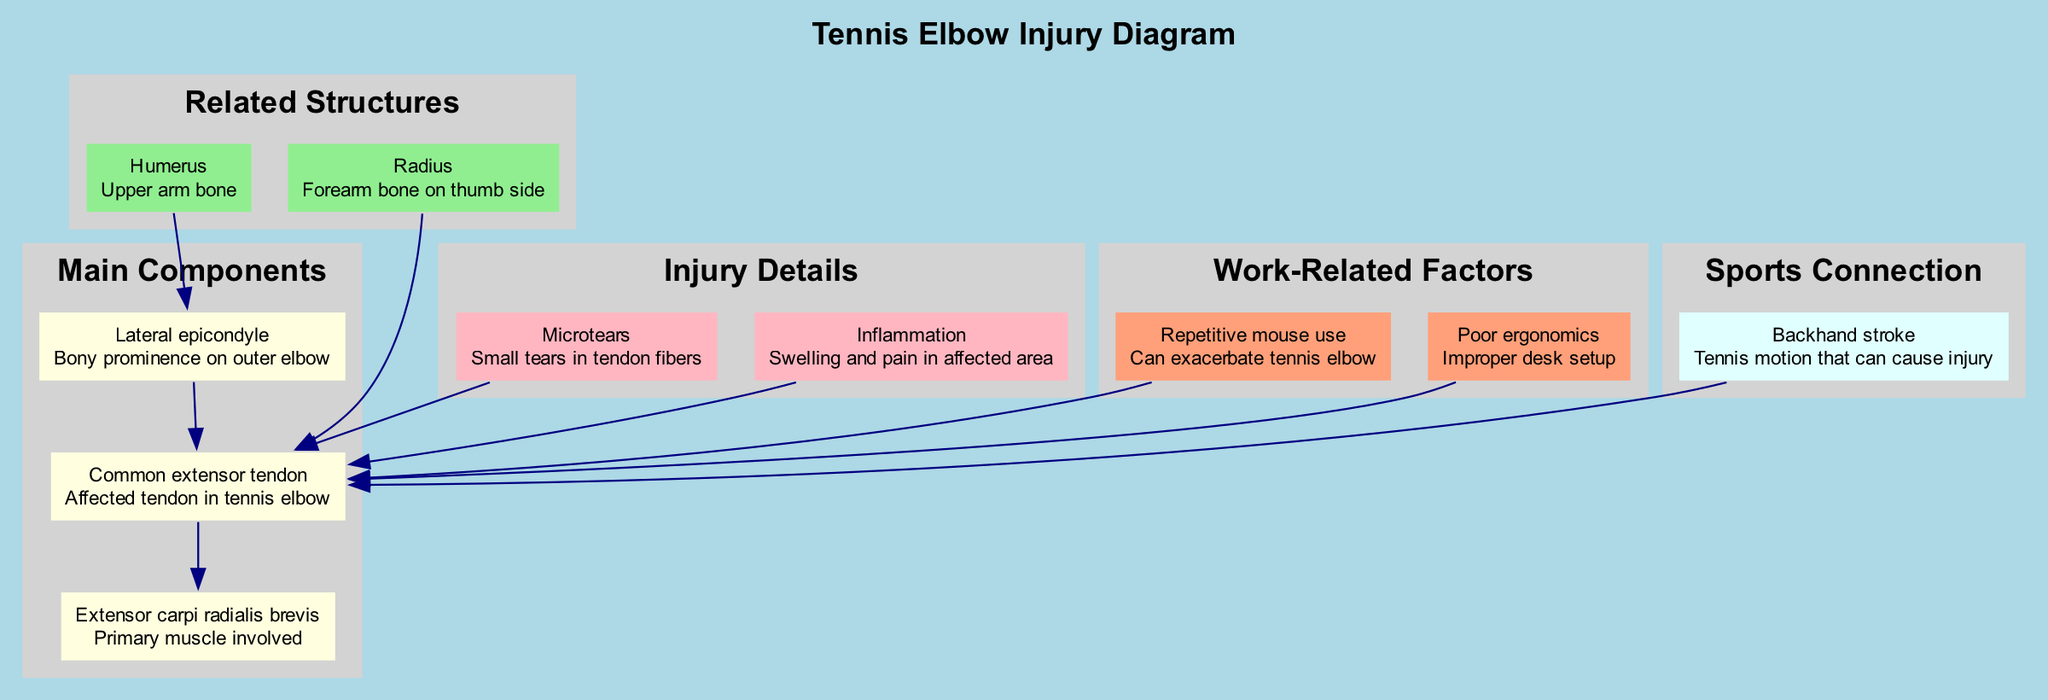What is the main tendon affected in a tennis elbow injury? The diagram indicates that the "Common extensor tendon" is the tendon affected in a tennis elbow injury. This is the primary tendon labeled in the main components section of the diagram.
Answer: Common extensor tendon How many main components are identified in the diagram? The diagram lists three main components: Lateral epicondyle, Common extensor tendon, and Extensor carpi radialis brevis. Counting these items gives a total of three main components.
Answer: 3 Which structure is shown as related to the Lateral epicondyle? The diagram indicates that the "Humerus" is a related structure to the Lateral epicondyle, as represented by an edge connecting the two nodes.
Answer: Humerus What type of injury is associated with Microtears? According to the diagram, Microtears are described as "Small tears in tendon fibers" which relates directly to the injury details linked to the Common extensor tendon. This means Microtears are associated with tendon injuries like tennis elbow.
Answer: Tennis elbow Which work-related factor can exacerbate tennis elbow? The diagram identifies "Repetitive mouse use" as a work-related factor that can exacerbate tennis elbow, showing a direct connection to the Common extensor tendon node in the injury details.
Answer: Repetitive mouse use How does the Backhand stroke relate to tennis elbow injuries? The diagram connects the "Backhand stroke" directly to the "Common extensor tendon," suggesting that this specific tennis motion is a cause of the injury. This establishes a clear link between the sport connection and the injury details.
Answer: Cause of injury Is the Extensor carpi radialis brevis a muscle involved in the injury? Yes, the Extensor carpi radialis brevis is identified as the "Primary muscle involved" in the injury, directly listed among the main components, confirming its involvement.
Answer: Yes What does inflammation refer to in the context of this diagram? The diagram describes inflammation as "Swelling and pain in affected area," providing a clear association with the injury details, indicating how it affects the individual dealing with tennis elbow.
Answer: Swelling and pain 